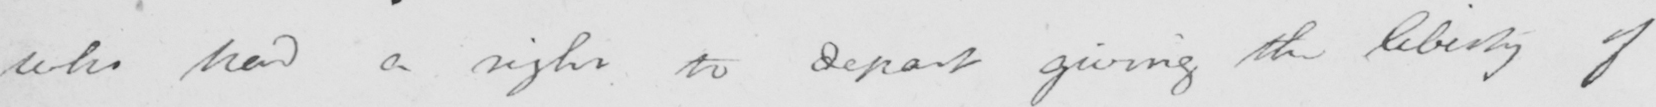What does this handwritten line say? who had a right to depart giving the liberty of 